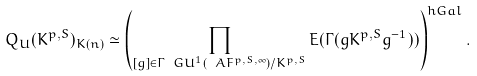Convert formula to latex. <formula><loc_0><loc_0><loc_500><loc_500>Q _ { U } ( K ^ { p , S } ) _ { K ( n ) } \simeq \left ( \prod _ { [ g ] \in \Gamma \ G U ^ { 1 } ( \ A F ^ { p , S , \infty } ) / K ^ { p , S } } E ( \Gamma ( g K ^ { p , S } g ^ { - 1 } ) ) \right ) ^ { h G a l } .</formula> 